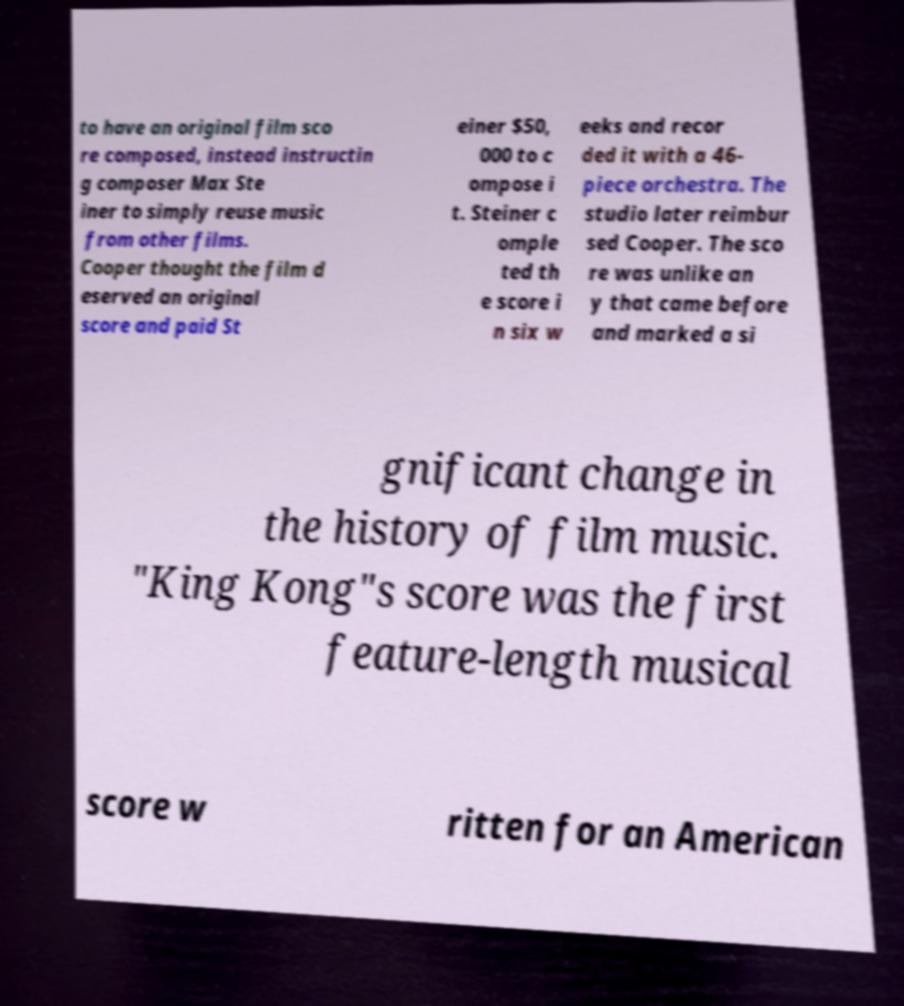What messages or text are displayed in this image? I need them in a readable, typed format. to have an original film sco re composed, instead instructin g composer Max Ste iner to simply reuse music from other films. Cooper thought the film d eserved an original score and paid St einer $50, 000 to c ompose i t. Steiner c omple ted th e score i n six w eeks and recor ded it with a 46- piece orchestra. The studio later reimbur sed Cooper. The sco re was unlike an y that came before and marked a si gnificant change in the history of film music. "King Kong"s score was the first feature-length musical score w ritten for an American 